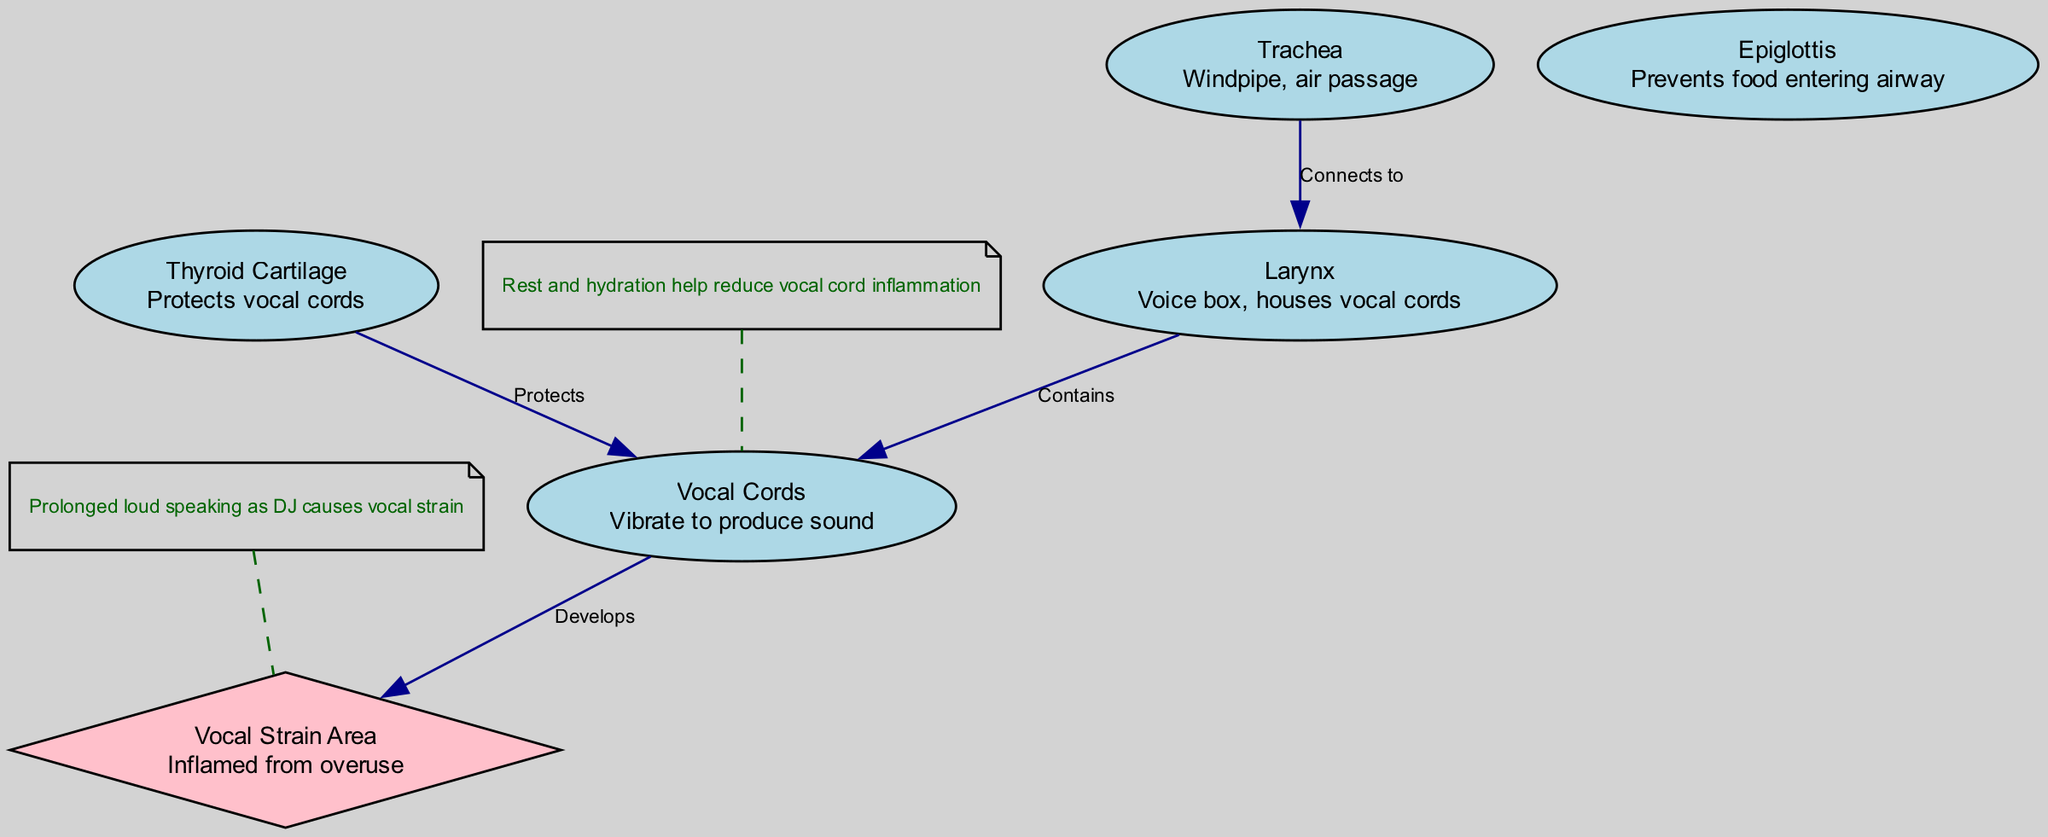What are the main components highlighted in the diagram? The diagram lists the Larynx, Vocal Cords, Thyroid Cartilage, Epiglottis, Trachea, and Vocal Strain Area as the main components. These are all nodes included in the data structure provided.
Answer: Larynx, Vocal Cords, Thyroid Cartilage, Epiglottis, Trachea, Vocal Strain Area How many nodes are present in the diagram? To determine the number of nodes, we count the items listed under the "nodes" section of the data provided. There are six nodes in total.
Answer: 6 What is the relationship between the Larynx and Vocal Cords? The edge connecting the Larynx to the Vocal Cords is labeled "Contains," indicating that the Larynx houses the Vocal Cords.
Answer: Contains Which area develops from the Vocal Cords? According to the edge connecting Vocal Cords to the strain area, it is indicated that the Vocal Strain Area "Develops" from the Vocal Cords due to overuse.
Answer: Vocal Strain Area What does prolonged loud speaking as a DJ cause? The annotation linked to the Vocal Strain Area states that "Prolonged loud speaking as DJ causes vocal strain," explaining the impact on vocal health.
Answer: Vocal strain What protects the Vocal Cords? The Thyroid Cartilage is labeled as "Protects" in the edge connecting it to the Vocal Cords, signifying its protective role.
Answer: Thyroid Cartilage What is the function of the Epiglottis? The Epiglottis is described as preventing food from entering the airway, which highlights its protective function within the throat region.
Answer: Prevents food entering airway What helps reduce vocal cord inflammation? The annotation connected to the Vocal Cords states that "Rest and hydration help reduce vocal cord inflammation," indicating these measures as effective.
Answer: Rest and hydration 